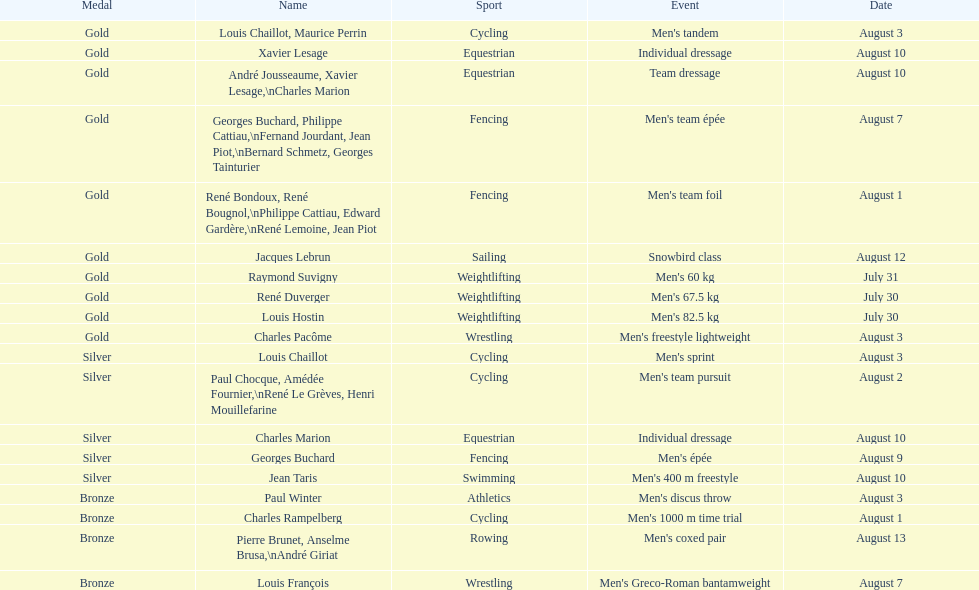In which sport did louis chaillot win a silver medal, in addition to his gold medal in cycling? Cycling. 